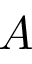Convert formula to latex. <formula><loc_0><loc_0><loc_500><loc_500>A</formula> 